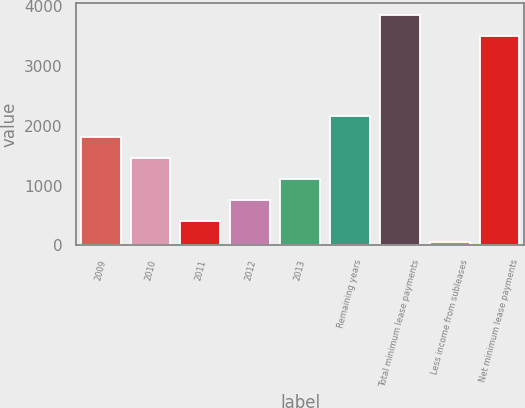<chart> <loc_0><loc_0><loc_500><loc_500><bar_chart><fcel>2009<fcel>2010<fcel>2011<fcel>2012<fcel>2013<fcel>Remaining years<fcel>Total minimum lease payments<fcel>Less income from subleases<fcel>Net minimum lease payments<nl><fcel>1810.5<fcel>1460.4<fcel>410.1<fcel>760.2<fcel>1110.3<fcel>2160.6<fcel>3851.1<fcel>60<fcel>3501<nl></chart> 